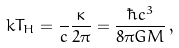<formula> <loc_0><loc_0><loc_500><loc_500>k T _ { H } = \frac { } { c } \frac { \kappa } { 2 \pi } = \frac { \hbar { c } ^ { 3 } } { 8 \pi G M } \, ,</formula> 